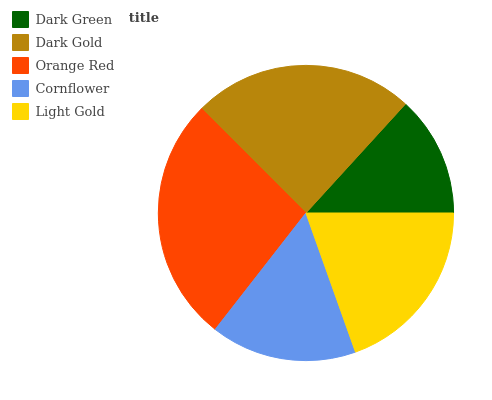Is Dark Green the minimum?
Answer yes or no. Yes. Is Orange Red the maximum?
Answer yes or no. Yes. Is Dark Gold the minimum?
Answer yes or no. No. Is Dark Gold the maximum?
Answer yes or no. No. Is Dark Gold greater than Dark Green?
Answer yes or no. Yes. Is Dark Green less than Dark Gold?
Answer yes or no. Yes. Is Dark Green greater than Dark Gold?
Answer yes or no. No. Is Dark Gold less than Dark Green?
Answer yes or no. No. Is Light Gold the high median?
Answer yes or no. Yes. Is Light Gold the low median?
Answer yes or no. Yes. Is Cornflower the high median?
Answer yes or no. No. Is Dark Gold the low median?
Answer yes or no. No. 